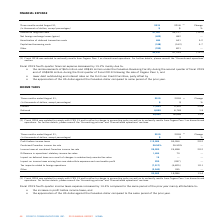According to Cogeco's financial document, What was the financial expense decrease in fourth-quarter 2019? According to the financial document, 15.2%. The relevant text states: "2019 fourth-quarter financial expense decreased by 15.2% mainly due to:..." Also, What was the reimbursement in 2019 fourth quarter? $65 million and US$35 million. The document states: "• the reimbursements of $65 million and US$35 million under the Canadian Revolving Facility during the second quarter of fiscal 2019 and of US$328 mil..." Also, What was the percentage decrease in the interest on long-term debt from 2018 to 2019? According to the financial document, 10.4 (percentage). The relevant text states: "Interest on long-term debt 41,307 46,127 (10.4)..." Also, can you calculate: What was the increase / (decrease) in the interest on long-term debt from 2018 to 2019? Based on the calculation: 41,307 - 46,127, the result is -4820 (in thousands). This is based on the information: "Interest on long-term debt 41,307 46,127 (10.4) Interest on long-term debt 41,307 46,127 (10.4)..." The key data points involved are: 41,307, 46,127. Also, can you calculate: What was the average Amortization of deferred transaction costs from 2018 to 2019? To answer this question, I need to perform calculations using the financial data. The calculation is: (464 + 441) / 2, which equals 452.5 (in thousands). This is based on the information: "Amortization of deferred transaction costs 464 441 5.2 Amortization of deferred transaction costs 464 441 5.2..." The key data points involved are: 441, 464. Also, can you calculate: What was the increase / (decrease) in total financial expense from 2018 to 2019? Based on the calculation: 40,437 - 47,709, the result is -7272 (in thousands). This is based on the information: "40,437 47,709 (15.2) 40,437 47,709 (15.2)..." The key data points involved are: 40,437, 47,709. 